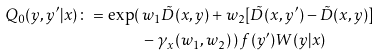<formula> <loc_0><loc_0><loc_500><loc_500>Q _ { 0 } ( y , y ^ { \prime } | x ) \colon = \exp ( \, & w _ { 1 } \tilde { D } ( x , y ) + w _ { 2 } [ \tilde { D } ( x , y ^ { \prime } ) - \tilde { D } ( x , y ) ] \\ & - \gamma _ { x } ( w _ { 1 } , w _ { 2 } ) \, ) \, f ( y ^ { \prime } ) W ( y | x )</formula> 